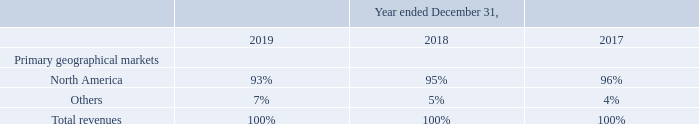Disaggregation of revenue
The following table provides information about disaggregated revenue by primary geographical markets:
The Company derived over 90%, and approximately 88% and 84% of subscription revenues from RingCentral Office product for the years ended December 31, 2019, 2018 and 2017, respectively
What are the respective percentage of subscription revenue derived in the years ended December 2017 and 2018? 84%, 88%. What are the respective percentage of subscription revenue derived in the years ended December 2018 and 2019? 88%, over 90%. What are the respective percentage of total revenue earned from North America in 2018 and 2019? 95%, 93%. What is the change in percentage of total revenue earned in North America between 2017 and 2018?
Answer scale should be: percent. 95-96
Answer: -1. What is the change in percentage of total revenue earned in North America between 2018 and 2019?
Answer scale should be: percent. 93-95
Answer: -2. What is the average percentage of revenue earned in North America between 2017 to 2019?
Answer scale should be: percent. (93 + 95 +96)/3 
Answer: 94.67. 